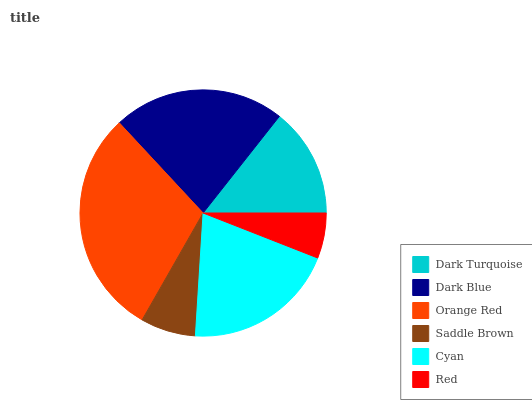Is Red the minimum?
Answer yes or no. Yes. Is Orange Red the maximum?
Answer yes or no. Yes. Is Dark Blue the minimum?
Answer yes or no. No. Is Dark Blue the maximum?
Answer yes or no. No. Is Dark Blue greater than Dark Turquoise?
Answer yes or no. Yes. Is Dark Turquoise less than Dark Blue?
Answer yes or no. Yes. Is Dark Turquoise greater than Dark Blue?
Answer yes or no. No. Is Dark Blue less than Dark Turquoise?
Answer yes or no. No. Is Cyan the high median?
Answer yes or no. Yes. Is Dark Turquoise the low median?
Answer yes or no. Yes. Is Dark Blue the high median?
Answer yes or no. No. Is Cyan the low median?
Answer yes or no. No. 